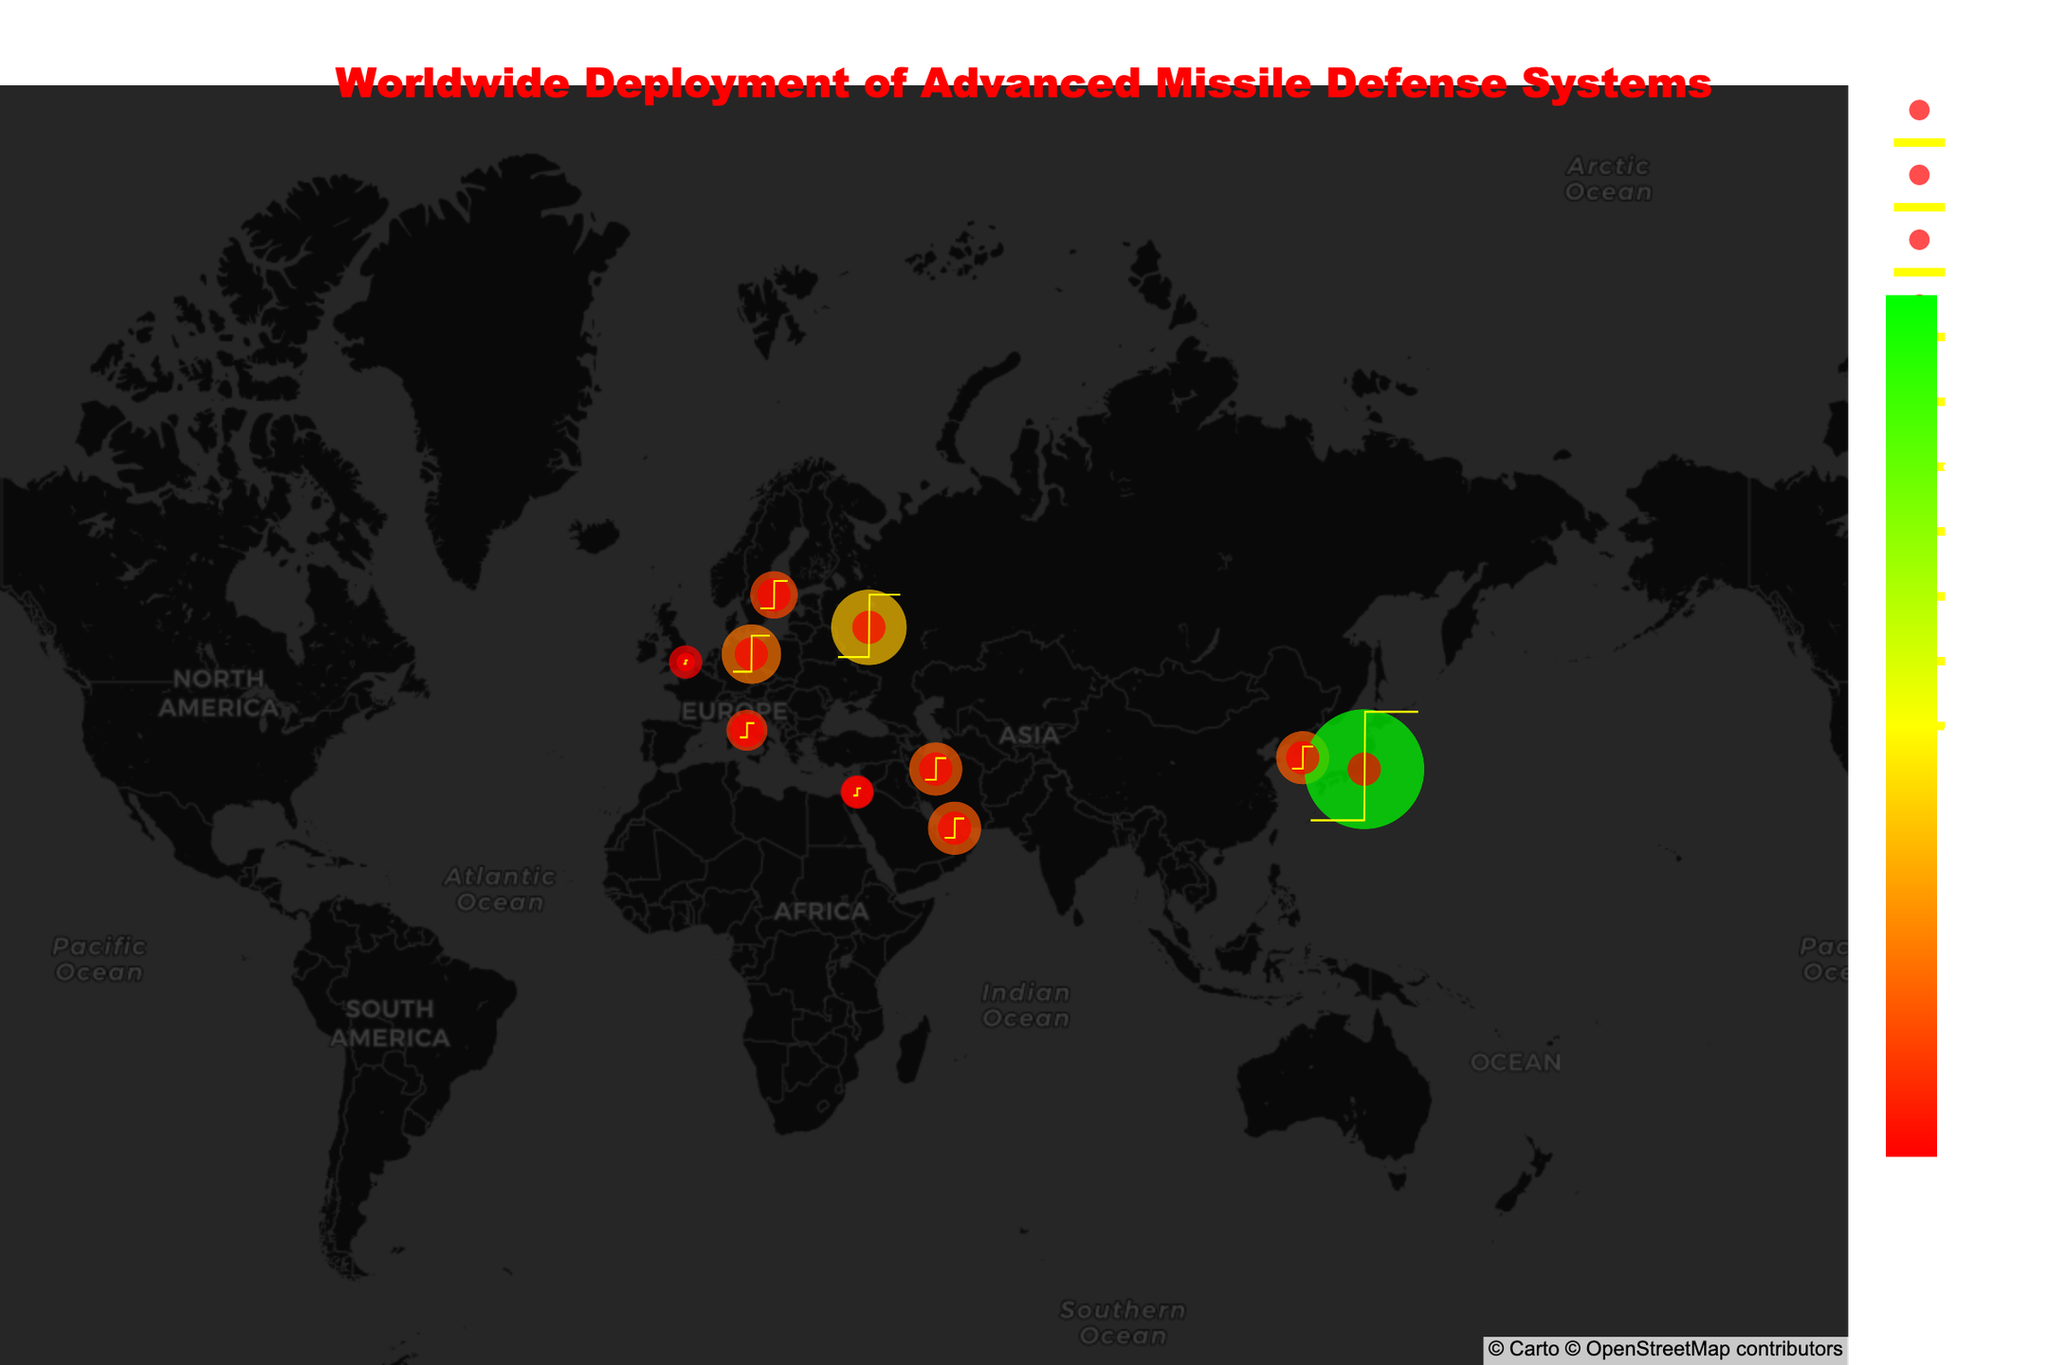1. What is the title of the figure? The title of the figure can be found at the top of the plot. It reads "Worldwide Deployment of Advanced Missile Defense Systems".
Answer: Worldwide Deployment of Advanced Missile Defense Systems 2. How many countries are represented in the figure? To determine the number of countries, we count the unique country labels in the figure: Germany, South Korea, Japan, Israel, UAE, Sweden, Italy, UK, Iran, Russia.
Answer: 10 3. Which defense system has the largest coverage radius and which country is it deployed in? By looking at the sizes of the circular areas and corresponding coverage radius labels, the largest coverage radius is 1000 km for the Aegis Ashore system in Japan.
Answer: Aegis Ashore, Japan 4. Is there any country with more than one missile defense system deployed? To determine this, we examine the hover labels and locations. Each country is associated with only one defense system in the figure.
Answer: No 5. Which interceptor type is most frequently deployed and how many countries use it? By comparing the interceptor types mentioned in the hover labels, "THAAD Interceptor" appears in South Korea and UAE. No other interceptor type appears more than once.
Answer: THAAD Interceptor, 2 6. What is the combined coverage radius of systems deployed in Europe? Germany (250 km), Sweden (160 km), Italy (120 km), and UK (25 km). Adding these up gives 250 + 160 + 120 + 25 = 555 km.
Answer: 555 km 7. Which system has the smallest coverage radius and which country is it deployed in? By comparing the sizes of the circular areas and the corresponding coverage radius labels, the smallest coverage radius is 25 km for the Sky Sabre system in the UK.
Answer: Sky Sabre, UK 8. If you are planning a coverage area in the Middle East, which two countries have the largest combined coverage radius? In the Middle East, we look at UAE (200 km), Israel (70 km), and Iran (200 km). The largest combined coverage is UAE and Iran with 200 + 200 = 400 km.
Answer: UAE and Iran 9. What coverage radius color represents the highest range of values and what color does it change to at lower values? By examining the color scale, the highest range of coverage radius is represented in green, transitioning to yellow and then to red at lower values.
Answer: Green, red 10. Which country has a defense system with a coverage radius over 300 km? By checking for countries with a coverage radius over 300 km, we find only Russia (400 km) and Japan (1000 km) meeting this criterion.
Answer: Russia, Japan 